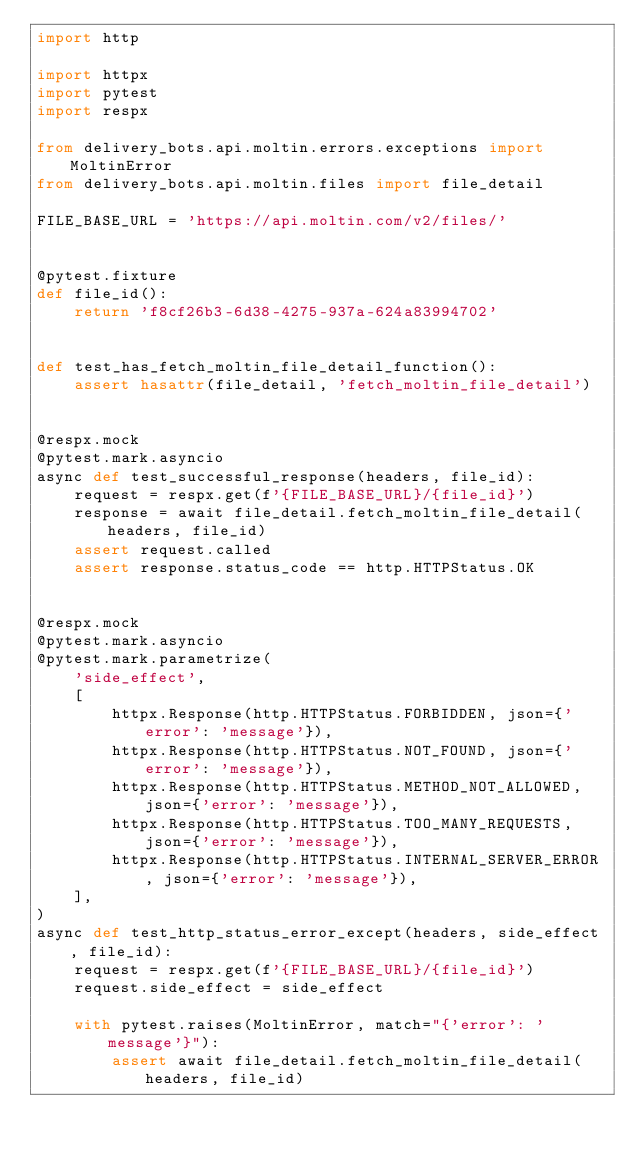<code> <loc_0><loc_0><loc_500><loc_500><_Python_>import http

import httpx
import pytest
import respx

from delivery_bots.api.moltin.errors.exceptions import MoltinError
from delivery_bots.api.moltin.files import file_detail

FILE_BASE_URL = 'https://api.moltin.com/v2/files/'


@pytest.fixture
def file_id():
    return 'f8cf26b3-6d38-4275-937a-624a83994702'


def test_has_fetch_moltin_file_detail_function():
    assert hasattr(file_detail, 'fetch_moltin_file_detail')


@respx.mock
@pytest.mark.asyncio
async def test_successful_response(headers, file_id):
    request = respx.get(f'{FILE_BASE_URL}/{file_id}')
    response = await file_detail.fetch_moltin_file_detail(headers, file_id)
    assert request.called
    assert response.status_code == http.HTTPStatus.OK


@respx.mock
@pytest.mark.asyncio
@pytest.mark.parametrize(
    'side_effect',
    [
        httpx.Response(http.HTTPStatus.FORBIDDEN, json={'error': 'message'}),
        httpx.Response(http.HTTPStatus.NOT_FOUND, json={'error': 'message'}),
        httpx.Response(http.HTTPStatus.METHOD_NOT_ALLOWED, json={'error': 'message'}),
        httpx.Response(http.HTTPStatus.TOO_MANY_REQUESTS, json={'error': 'message'}),
        httpx.Response(http.HTTPStatus.INTERNAL_SERVER_ERROR, json={'error': 'message'}),
    ],
)
async def test_http_status_error_except(headers, side_effect, file_id):
    request = respx.get(f'{FILE_BASE_URL}/{file_id}')
    request.side_effect = side_effect

    with pytest.raises(MoltinError, match="{'error': 'message'}"):
        assert await file_detail.fetch_moltin_file_detail(headers, file_id)
</code> 